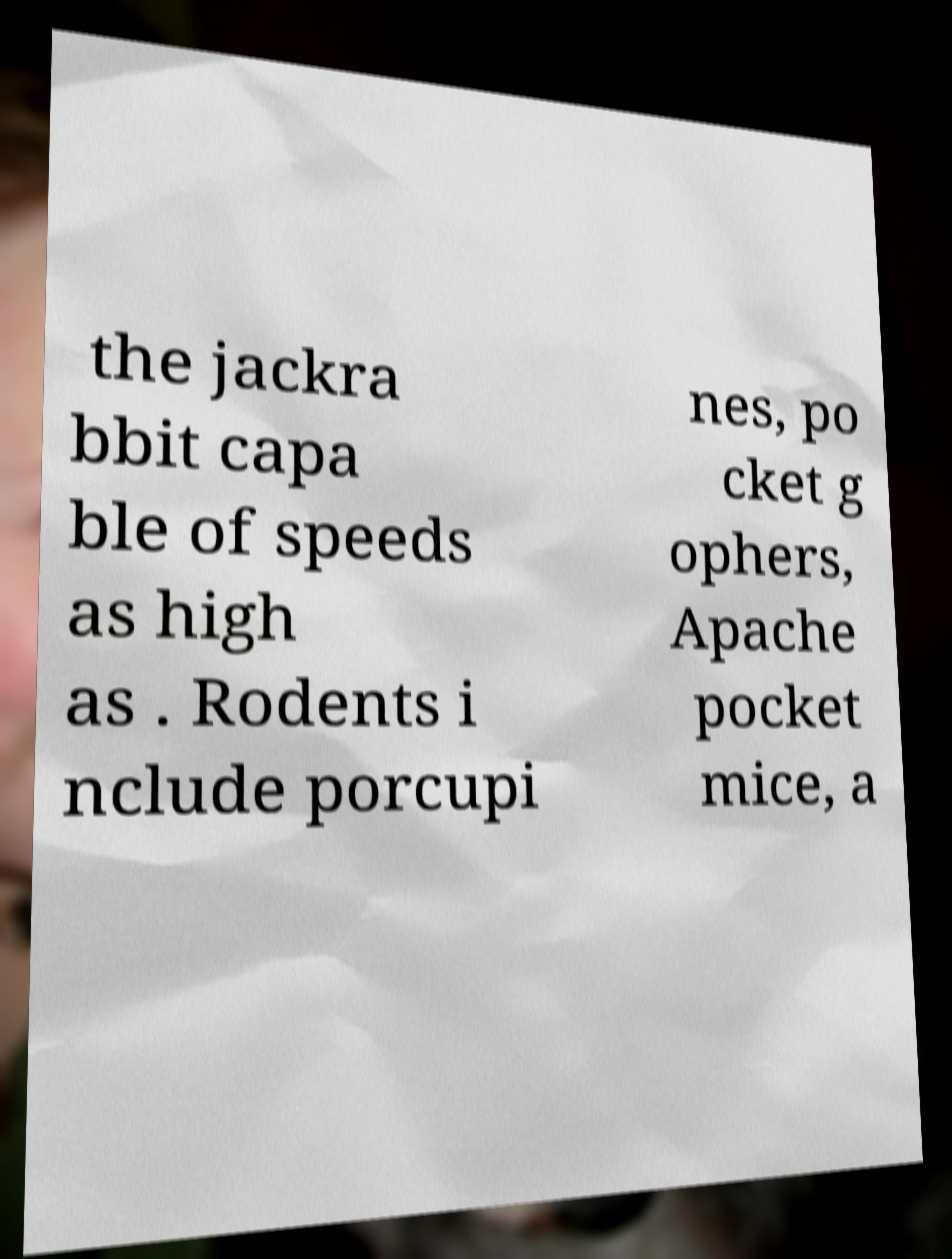Please identify and transcribe the text found in this image. the jackra bbit capa ble of speeds as high as . Rodents i nclude porcupi nes, po cket g ophers, Apache pocket mice, a 